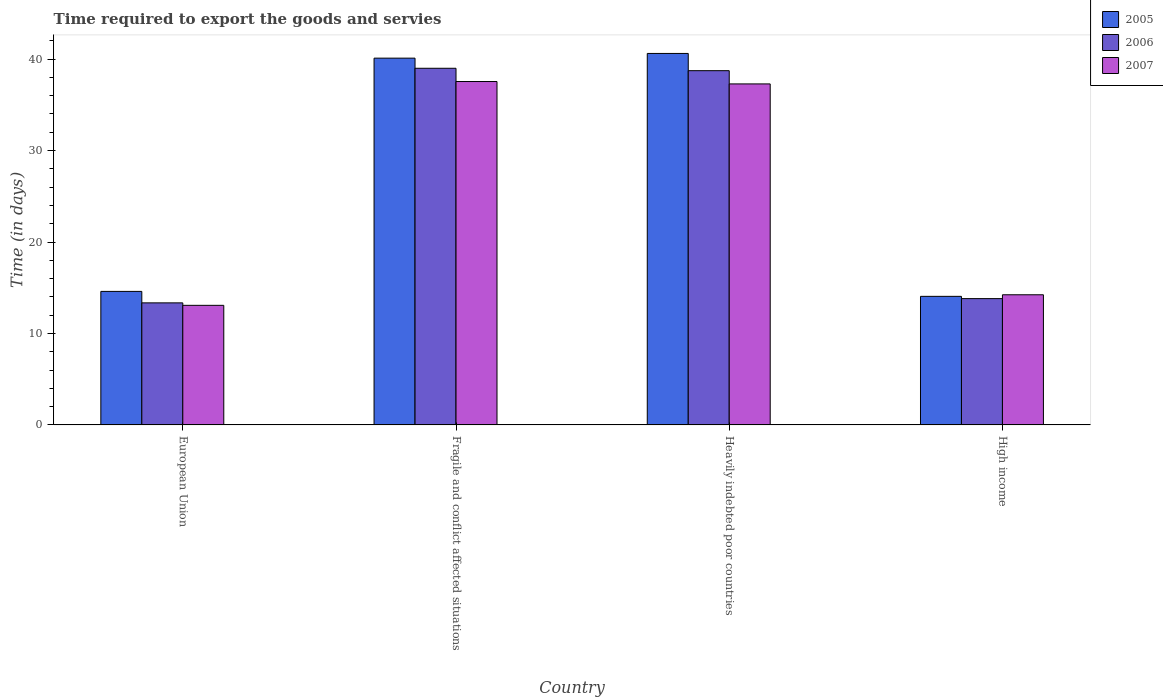How many groups of bars are there?
Provide a succinct answer. 4. Are the number of bars per tick equal to the number of legend labels?
Provide a short and direct response. Yes. How many bars are there on the 1st tick from the right?
Your response must be concise. 3. In how many cases, is the number of bars for a given country not equal to the number of legend labels?
Provide a succinct answer. 0. What is the number of days required to export the goods and services in 2006 in High income?
Offer a terse response. 13.81. Across all countries, what is the maximum number of days required to export the goods and services in 2006?
Your answer should be very brief. 39. Across all countries, what is the minimum number of days required to export the goods and services in 2007?
Keep it short and to the point. 13.08. In which country was the number of days required to export the goods and services in 2005 maximum?
Your answer should be very brief. Heavily indebted poor countries. What is the total number of days required to export the goods and services in 2005 in the graph?
Your response must be concise. 109.39. What is the difference between the number of days required to export the goods and services in 2005 in Fragile and conflict affected situations and that in High income?
Keep it short and to the point. 26.05. What is the difference between the number of days required to export the goods and services in 2005 in High income and the number of days required to export the goods and services in 2006 in Heavily indebted poor countries?
Your answer should be compact. -24.68. What is the average number of days required to export the goods and services in 2007 per country?
Offer a very short reply. 25.54. What is the difference between the number of days required to export the goods and services of/in 2006 and number of days required to export the goods and services of/in 2005 in European Union?
Give a very brief answer. -1.25. What is the ratio of the number of days required to export the goods and services in 2007 in European Union to that in High income?
Your answer should be very brief. 0.92. Is the number of days required to export the goods and services in 2006 in European Union less than that in High income?
Provide a short and direct response. Yes. What is the difference between the highest and the second highest number of days required to export the goods and services in 2005?
Your response must be concise. 0.51. What is the difference between the highest and the lowest number of days required to export the goods and services in 2007?
Your answer should be very brief. 24.47. Is the sum of the number of days required to export the goods and services in 2005 in Fragile and conflict affected situations and High income greater than the maximum number of days required to export the goods and services in 2007 across all countries?
Your response must be concise. Yes. What does the 1st bar from the left in European Union represents?
Offer a very short reply. 2005. What does the 3rd bar from the right in Fragile and conflict affected situations represents?
Your answer should be compact. 2005. Is it the case that in every country, the sum of the number of days required to export the goods and services in 2005 and number of days required to export the goods and services in 2007 is greater than the number of days required to export the goods and services in 2006?
Make the answer very short. Yes. How many bars are there?
Give a very brief answer. 12. Are all the bars in the graph horizontal?
Make the answer very short. No. Are the values on the major ticks of Y-axis written in scientific E-notation?
Offer a terse response. No. Where does the legend appear in the graph?
Ensure brevity in your answer.  Top right. How many legend labels are there?
Offer a very short reply. 3. What is the title of the graph?
Keep it short and to the point. Time required to export the goods and servies. Does "1987" appear as one of the legend labels in the graph?
Your response must be concise. No. What is the label or title of the X-axis?
Offer a very short reply. Country. What is the label or title of the Y-axis?
Give a very brief answer. Time (in days). What is the Time (in days) of 2005 in European Union?
Your answer should be very brief. 14.6. What is the Time (in days) in 2006 in European Union?
Make the answer very short. 13.35. What is the Time (in days) in 2007 in European Union?
Make the answer very short. 13.08. What is the Time (in days) in 2005 in Fragile and conflict affected situations?
Offer a very short reply. 40.11. What is the Time (in days) of 2006 in Fragile and conflict affected situations?
Your response must be concise. 39. What is the Time (in days) in 2007 in Fragile and conflict affected situations?
Offer a terse response. 37.55. What is the Time (in days) of 2005 in Heavily indebted poor countries?
Ensure brevity in your answer.  40.62. What is the Time (in days) in 2006 in Heavily indebted poor countries?
Keep it short and to the point. 38.74. What is the Time (in days) of 2007 in Heavily indebted poor countries?
Provide a succinct answer. 37.29. What is the Time (in days) in 2005 in High income?
Provide a short and direct response. 14.06. What is the Time (in days) of 2006 in High income?
Your answer should be compact. 13.81. What is the Time (in days) of 2007 in High income?
Your response must be concise. 14.23. Across all countries, what is the maximum Time (in days) of 2005?
Make the answer very short. 40.62. Across all countries, what is the maximum Time (in days) in 2007?
Offer a very short reply. 37.55. Across all countries, what is the minimum Time (in days) of 2005?
Provide a succinct answer. 14.06. Across all countries, what is the minimum Time (in days) of 2006?
Give a very brief answer. 13.35. Across all countries, what is the minimum Time (in days) in 2007?
Offer a very short reply. 13.08. What is the total Time (in days) in 2005 in the graph?
Keep it short and to the point. 109.39. What is the total Time (in days) of 2006 in the graph?
Your answer should be compact. 104.89. What is the total Time (in days) in 2007 in the graph?
Provide a short and direct response. 102.15. What is the difference between the Time (in days) in 2005 in European Union and that in Fragile and conflict affected situations?
Offer a very short reply. -25.51. What is the difference between the Time (in days) in 2006 in European Union and that in Fragile and conflict affected situations?
Your answer should be very brief. -25.65. What is the difference between the Time (in days) in 2007 in European Union and that in Fragile and conflict affected situations?
Keep it short and to the point. -24.47. What is the difference between the Time (in days) of 2005 in European Union and that in Heavily indebted poor countries?
Provide a succinct answer. -26.02. What is the difference between the Time (in days) in 2006 in European Union and that in Heavily indebted poor countries?
Your answer should be very brief. -25.39. What is the difference between the Time (in days) of 2007 in European Union and that in Heavily indebted poor countries?
Your answer should be very brief. -24.21. What is the difference between the Time (in days) in 2005 in European Union and that in High income?
Provide a succinct answer. 0.54. What is the difference between the Time (in days) in 2006 in European Union and that in High income?
Offer a very short reply. -0.47. What is the difference between the Time (in days) in 2007 in European Union and that in High income?
Your answer should be compact. -1.16. What is the difference between the Time (in days) in 2005 in Fragile and conflict affected situations and that in Heavily indebted poor countries?
Give a very brief answer. -0.51. What is the difference between the Time (in days) of 2006 in Fragile and conflict affected situations and that in Heavily indebted poor countries?
Make the answer very short. 0.26. What is the difference between the Time (in days) in 2007 in Fragile and conflict affected situations and that in Heavily indebted poor countries?
Your answer should be very brief. 0.26. What is the difference between the Time (in days) of 2005 in Fragile and conflict affected situations and that in High income?
Provide a short and direct response. 26.05. What is the difference between the Time (in days) in 2006 in Fragile and conflict affected situations and that in High income?
Keep it short and to the point. 25.19. What is the difference between the Time (in days) of 2007 in Fragile and conflict affected situations and that in High income?
Your response must be concise. 23.32. What is the difference between the Time (in days) in 2005 in Heavily indebted poor countries and that in High income?
Ensure brevity in your answer.  26.56. What is the difference between the Time (in days) in 2006 in Heavily indebted poor countries and that in High income?
Keep it short and to the point. 24.93. What is the difference between the Time (in days) in 2007 in Heavily indebted poor countries and that in High income?
Offer a very short reply. 23.06. What is the difference between the Time (in days) in 2005 in European Union and the Time (in days) in 2006 in Fragile and conflict affected situations?
Your answer should be compact. -24.4. What is the difference between the Time (in days) in 2005 in European Union and the Time (in days) in 2007 in Fragile and conflict affected situations?
Keep it short and to the point. -22.95. What is the difference between the Time (in days) in 2006 in European Union and the Time (in days) in 2007 in Fragile and conflict affected situations?
Give a very brief answer. -24.21. What is the difference between the Time (in days) in 2005 in European Union and the Time (in days) in 2006 in Heavily indebted poor countries?
Your answer should be very brief. -24.14. What is the difference between the Time (in days) in 2005 in European Union and the Time (in days) in 2007 in Heavily indebted poor countries?
Offer a terse response. -22.69. What is the difference between the Time (in days) in 2006 in European Union and the Time (in days) in 2007 in Heavily indebted poor countries?
Provide a short and direct response. -23.94. What is the difference between the Time (in days) of 2005 in European Union and the Time (in days) of 2006 in High income?
Offer a terse response. 0.79. What is the difference between the Time (in days) of 2005 in European Union and the Time (in days) of 2007 in High income?
Your answer should be compact. 0.37. What is the difference between the Time (in days) in 2006 in European Union and the Time (in days) in 2007 in High income?
Offer a terse response. -0.89. What is the difference between the Time (in days) in 2005 in Fragile and conflict affected situations and the Time (in days) in 2006 in Heavily indebted poor countries?
Keep it short and to the point. 1.37. What is the difference between the Time (in days) of 2005 in Fragile and conflict affected situations and the Time (in days) of 2007 in Heavily indebted poor countries?
Provide a short and direct response. 2.82. What is the difference between the Time (in days) in 2006 in Fragile and conflict affected situations and the Time (in days) in 2007 in Heavily indebted poor countries?
Offer a very short reply. 1.71. What is the difference between the Time (in days) in 2005 in Fragile and conflict affected situations and the Time (in days) in 2006 in High income?
Give a very brief answer. 26.3. What is the difference between the Time (in days) in 2005 in Fragile and conflict affected situations and the Time (in days) in 2007 in High income?
Your response must be concise. 25.88. What is the difference between the Time (in days) in 2006 in Fragile and conflict affected situations and the Time (in days) in 2007 in High income?
Your answer should be very brief. 24.77. What is the difference between the Time (in days) in 2005 in Heavily indebted poor countries and the Time (in days) in 2006 in High income?
Make the answer very short. 26.81. What is the difference between the Time (in days) of 2005 in Heavily indebted poor countries and the Time (in days) of 2007 in High income?
Make the answer very short. 26.39. What is the difference between the Time (in days) of 2006 in Heavily indebted poor countries and the Time (in days) of 2007 in High income?
Keep it short and to the point. 24.5. What is the average Time (in days) of 2005 per country?
Ensure brevity in your answer.  27.35. What is the average Time (in days) of 2006 per country?
Provide a succinct answer. 26.22. What is the average Time (in days) of 2007 per country?
Give a very brief answer. 25.54. What is the difference between the Time (in days) of 2005 and Time (in days) of 2006 in European Union?
Provide a short and direct response. 1.25. What is the difference between the Time (in days) in 2005 and Time (in days) in 2007 in European Union?
Your answer should be very brief. 1.52. What is the difference between the Time (in days) in 2006 and Time (in days) in 2007 in European Union?
Your response must be concise. 0.27. What is the difference between the Time (in days) of 2005 and Time (in days) of 2006 in Fragile and conflict affected situations?
Ensure brevity in your answer.  1.11. What is the difference between the Time (in days) of 2005 and Time (in days) of 2007 in Fragile and conflict affected situations?
Keep it short and to the point. 2.56. What is the difference between the Time (in days) of 2006 and Time (in days) of 2007 in Fragile and conflict affected situations?
Give a very brief answer. 1.45. What is the difference between the Time (in days) in 2005 and Time (in days) in 2006 in Heavily indebted poor countries?
Offer a terse response. 1.88. What is the difference between the Time (in days) in 2005 and Time (in days) in 2007 in Heavily indebted poor countries?
Offer a very short reply. 3.33. What is the difference between the Time (in days) in 2006 and Time (in days) in 2007 in Heavily indebted poor countries?
Offer a very short reply. 1.45. What is the difference between the Time (in days) in 2005 and Time (in days) in 2006 in High income?
Give a very brief answer. 0.25. What is the difference between the Time (in days) of 2005 and Time (in days) of 2007 in High income?
Give a very brief answer. -0.17. What is the difference between the Time (in days) in 2006 and Time (in days) in 2007 in High income?
Provide a succinct answer. -0.42. What is the ratio of the Time (in days) in 2005 in European Union to that in Fragile and conflict affected situations?
Provide a succinct answer. 0.36. What is the ratio of the Time (in days) of 2006 in European Union to that in Fragile and conflict affected situations?
Give a very brief answer. 0.34. What is the ratio of the Time (in days) in 2007 in European Union to that in Fragile and conflict affected situations?
Offer a terse response. 0.35. What is the ratio of the Time (in days) of 2005 in European Union to that in Heavily indebted poor countries?
Ensure brevity in your answer.  0.36. What is the ratio of the Time (in days) of 2006 in European Union to that in Heavily indebted poor countries?
Make the answer very short. 0.34. What is the ratio of the Time (in days) of 2007 in European Union to that in Heavily indebted poor countries?
Provide a succinct answer. 0.35. What is the ratio of the Time (in days) of 2005 in European Union to that in High income?
Your response must be concise. 1.04. What is the ratio of the Time (in days) of 2006 in European Union to that in High income?
Make the answer very short. 0.97. What is the ratio of the Time (in days) of 2007 in European Union to that in High income?
Make the answer very short. 0.92. What is the ratio of the Time (in days) in 2005 in Fragile and conflict affected situations to that in Heavily indebted poor countries?
Provide a short and direct response. 0.99. What is the ratio of the Time (in days) in 2006 in Fragile and conflict affected situations to that in Heavily indebted poor countries?
Give a very brief answer. 1.01. What is the ratio of the Time (in days) in 2007 in Fragile and conflict affected situations to that in Heavily indebted poor countries?
Provide a succinct answer. 1.01. What is the ratio of the Time (in days) of 2005 in Fragile and conflict affected situations to that in High income?
Your response must be concise. 2.85. What is the ratio of the Time (in days) in 2006 in Fragile and conflict affected situations to that in High income?
Offer a very short reply. 2.82. What is the ratio of the Time (in days) of 2007 in Fragile and conflict affected situations to that in High income?
Make the answer very short. 2.64. What is the ratio of the Time (in days) in 2005 in Heavily indebted poor countries to that in High income?
Your response must be concise. 2.89. What is the ratio of the Time (in days) of 2006 in Heavily indebted poor countries to that in High income?
Your response must be concise. 2.8. What is the ratio of the Time (in days) of 2007 in Heavily indebted poor countries to that in High income?
Your answer should be compact. 2.62. What is the difference between the highest and the second highest Time (in days) of 2005?
Make the answer very short. 0.51. What is the difference between the highest and the second highest Time (in days) of 2006?
Offer a very short reply. 0.26. What is the difference between the highest and the second highest Time (in days) of 2007?
Make the answer very short. 0.26. What is the difference between the highest and the lowest Time (in days) in 2005?
Provide a short and direct response. 26.56. What is the difference between the highest and the lowest Time (in days) of 2006?
Your answer should be very brief. 25.65. What is the difference between the highest and the lowest Time (in days) of 2007?
Your answer should be very brief. 24.47. 